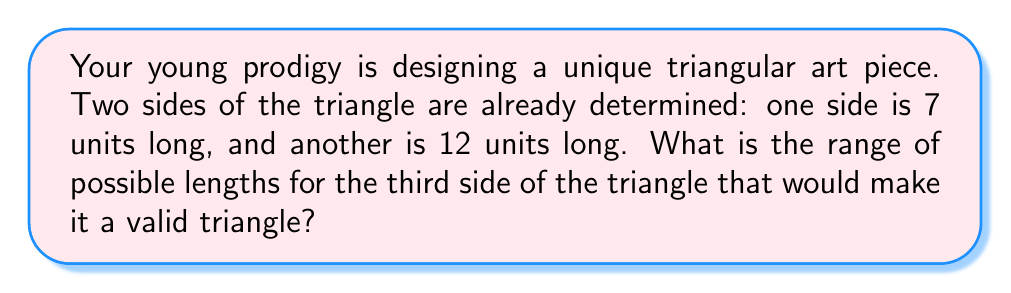Provide a solution to this math problem. Let's approach this step-by-step using the triangle inequality theorem:

1) The triangle inequality theorem states that the sum of any two sides of a triangle must be greater than the third side, and the difference between any two sides must be less than the third side.

2) Let's denote the unknown third side as $x$. We know that:
   Side a = 7
   Side b = 12
   Side c = $x$

3) Applying the theorem, we get three inequalities:
   $a + b > c$: $7 + 12 > x$, simplifies to $19 > x$
   $a + c > b$: $7 + x > 12$, simplifies to $x > 5$
   $b + c > a$: $12 + x > 7$, simplifies to $x > -5$ (always true for positive lengths)

4) Combining these inequalities:
   $5 < x < 19$

5) However, we also need to consider the reverse inequalities:
   $|a - b| < c$: $|7 - 12| < x$, simplifies to $5 < x$

6) This last inequality is already satisfied by our combined inequality from step 4.

7) Therefore, the final range for the third side $x$ is:
   $5 < x < 19$

8) Since we're dealing with lengths, $x$ must be positive. The lower bound is already positive, so we don't need to adjust it.
Answer: $5 < x < 19$ 